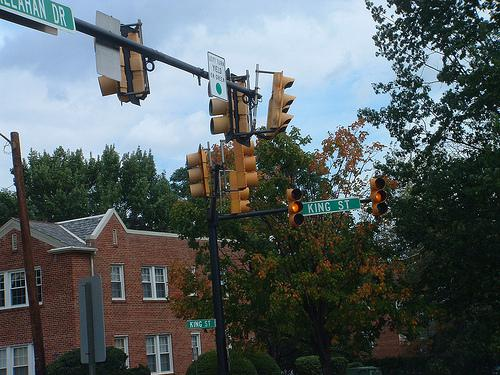Question: what is the building made of?
Choices:
A. Cinder blocks.
B. Wood.
C. Brick.
D. Metal.
Answer with the letter. Answer: C Question: how many street name signs are totally or partially visible?
Choices:
A. Four.
B. One.
C. Two.
D. Three.
Answer with the letter. Answer: D Question: what corner of the photo has a street name sign that does not say King St.?
Choices:
A. Top right.
B. Bottom left.
C. Bottom right.
D. Top left.
Answer with the letter. Answer: D 